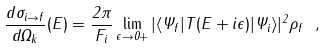<formula> <loc_0><loc_0><loc_500><loc_500>\frac { d \sigma _ { i \to f } } { d \Omega _ { k } } ( E ) = \frac { 2 \pi } { F _ { i } } \lim _ { \epsilon \to 0 + } | \langle \Psi _ { f } | T ( E + i \epsilon ) | \Psi _ { i } \rangle | ^ { 2 } \rho _ { f } \ ,</formula> 